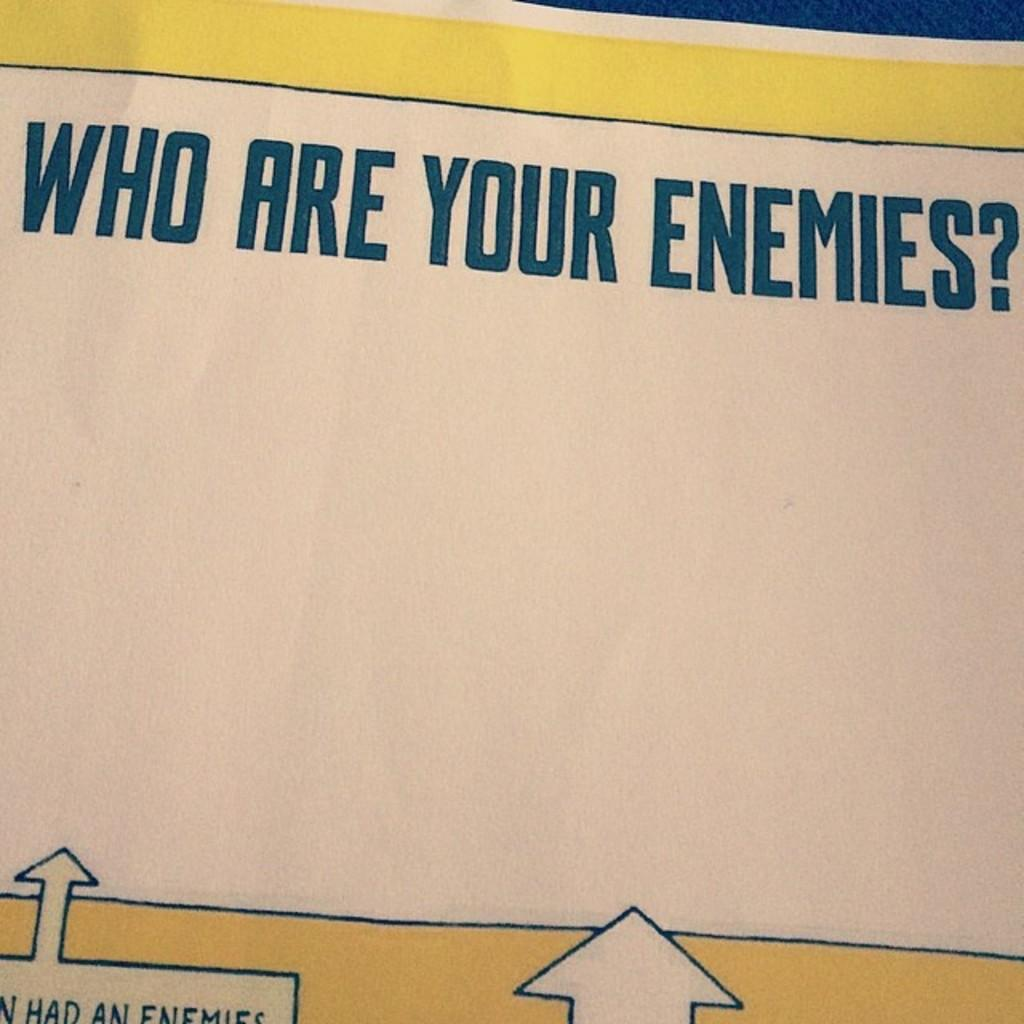<image>
Offer a succinct explanation of the picture presented. A yellow and white sign that reads Who are your enemies in large blue letters. 